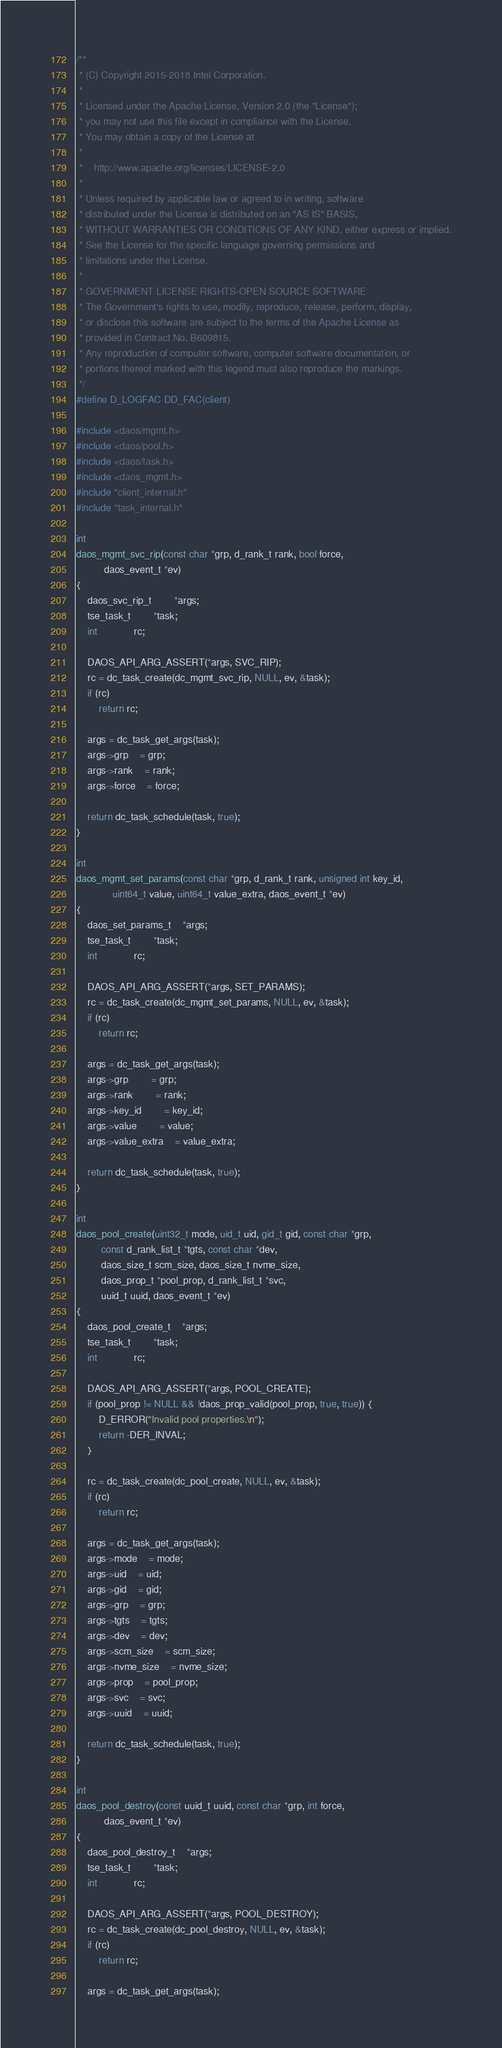<code> <loc_0><loc_0><loc_500><loc_500><_C_>/**
 * (C) Copyright 2015-2018 Intel Corporation.
 *
 * Licensed under the Apache License, Version 2.0 (the "License");
 * you may not use this file except in compliance with the License.
 * You may obtain a copy of the License at
 *
 *    http://www.apache.org/licenses/LICENSE-2.0
 *
 * Unless required by applicable law or agreed to in writing, software
 * distributed under the License is distributed on an "AS IS" BASIS,
 * WITHOUT WARRANTIES OR CONDITIONS OF ANY KIND, either express or implied.
 * See the License for the specific language governing permissions and
 * limitations under the License.
 *
 * GOVERNMENT LICENSE RIGHTS-OPEN SOURCE SOFTWARE
 * The Government's rights to use, modify, reproduce, release, perform, display,
 * or disclose this software are subject to the terms of the Apache License as
 * provided in Contract No. B609815.
 * Any reproduction of computer software, computer software documentation, or
 * portions thereof marked with this legend must also reproduce the markings.
 */
#define D_LOGFAC	DD_FAC(client)

#include <daos/mgmt.h>
#include <daos/pool.h>
#include <daos/task.h>
#include <daos_mgmt.h>
#include "client_internal.h"
#include "task_internal.h"

int
daos_mgmt_svc_rip(const char *grp, d_rank_t rank, bool force,
		  daos_event_t *ev)
{
	daos_svc_rip_t		*args;
	tse_task_t		*task;
	int			 rc;

	DAOS_API_ARG_ASSERT(*args, SVC_RIP);
	rc = dc_task_create(dc_mgmt_svc_rip, NULL, ev, &task);
	if (rc)
		return rc;

	args = dc_task_get_args(task);
	args->grp	= grp;
	args->rank	= rank;
	args->force	= force;

	return dc_task_schedule(task, true);
}

int
daos_mgmt_set_params(const char *grp, d_rank_t rank, unsigned int key_id,
		     uint64_t value, uint64_t value_extra, daos_event_t *ev)
{
	daos_set_params_t	*args;
	tse_task_t		*task;
	int			 rc;

	DAOS_API_ARG_ASSERT(*args, SET_PARAMS);
	rc = dc_task_create(dc_mgmt_set_params, NULL, ev, &task);
	if (rc)
		return rc;

	args = dc_task_get_args(task);
	args->grp		= grp;
	args->rank		= rank;
	args->key_id		= key_id;
	args->value		= value;
	args->value_extra	= value_extra;

	return dc_task_schedule(task, true);
}

int
daos_pool_create(uint32_t mode, uid_t uid, gid_t gid, const char *grp,
		 const d_rank_list_t *tgts, const char *dev,
		 daos_size_t scm_size, daos_size_t nvme_size,
		 daos_prop_t *pool_prop, d_rank_list_t *svc,
		 uuid_t uuid, daos_event_t *ev)
{
	daos_pool_create_t	*args;
	tse_task_t		*task;
	int			 rc;

	DAOS_API_ARG_ASSERT(*args, POOL_CREATE);
	if (pool_prop != NULL && !daos_prop_valid(pool_prop, true, true)) {
		D_ERROR("Invalid pool properties.\n");
		return -DER_INVAL;
	}

	rc = dc_task_create(dc_pool_create, NULL, ev, &task);
	if (rc)
		return rc;

	args = dc_task_get_args(task);
	args->mode	= mode;
	args->uid	= uid;
	args->gid	= gid;
	args->grp	= grp;
	args->tgts	= tgts;
	args->dev	= dev;
	args->scm_size	= scm_size;
	args->nvme_size	= nvme_size;
	args->prop	= pool_prop;
	args->svc	= svc;
	args->uuid	= uuid;

	return dc_task_schedule(task, true);
}

int
daos_pool_destroy(const uuid_t uuid, const char *grp, int force,
		  daos_event_t *ev)
{
	daos_pool_destroy_t	*args;
	tse_task_t		*task;
	int			 rc;

	DAOS_API_ARG_ASSERT(*args, POOL_DESTROY);
	rc = dc_task_create(dc_pool_destroy, NULL, ev, &task);
	if (rc)
		return rc;

	args = dc_task_get_args(task);</code> 